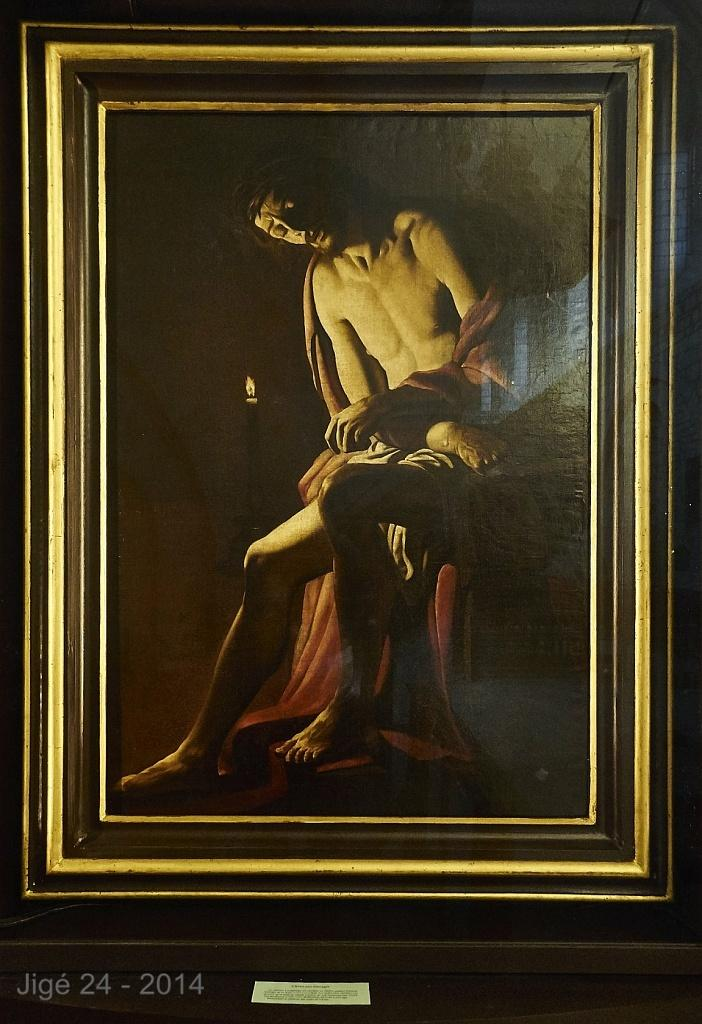<image>
Summarize the visual content of the image. An oil painting with a foreign date from 2014 